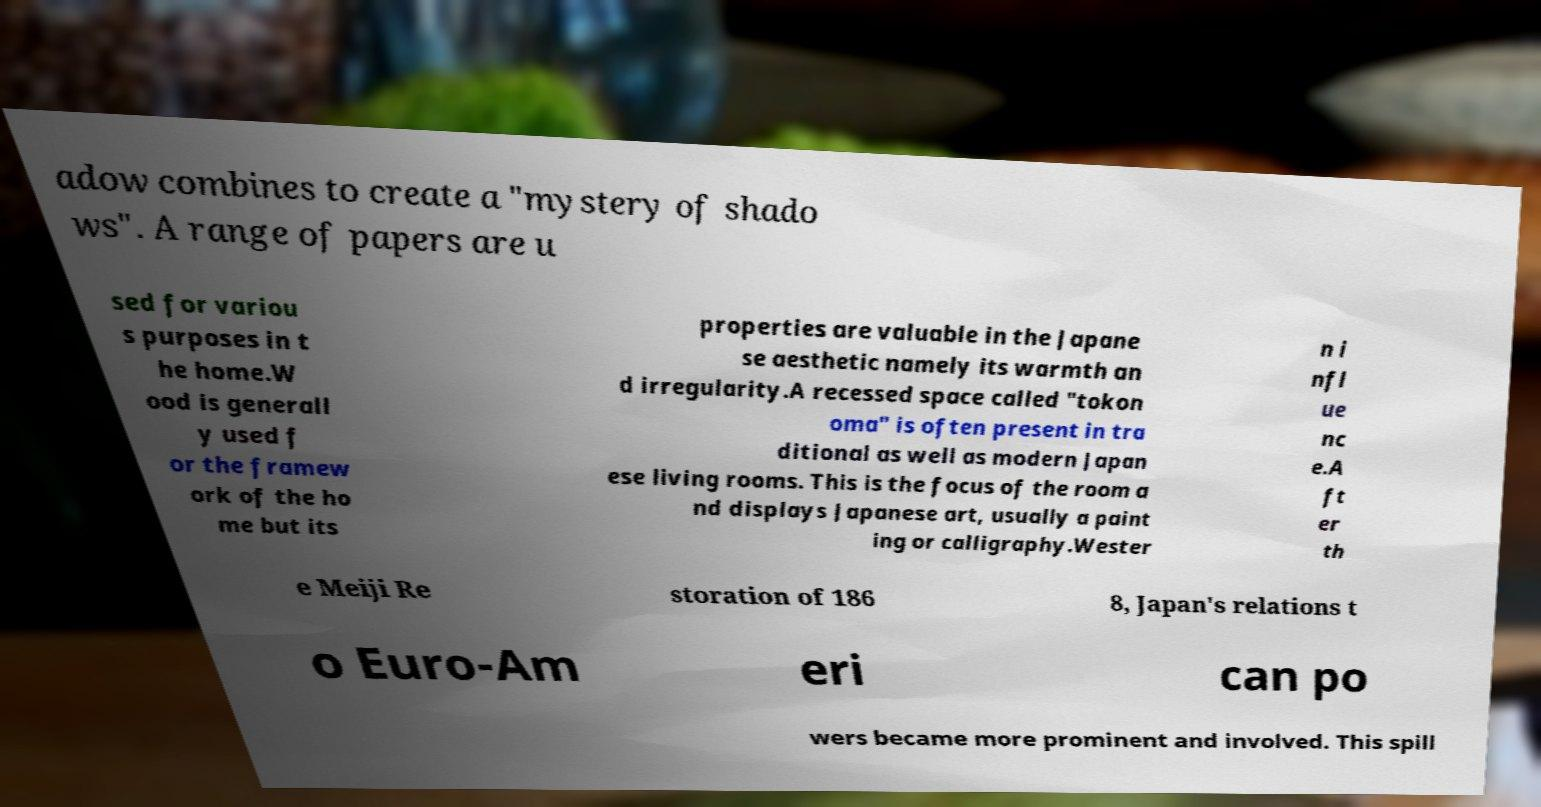Please identify and transcribe the text found in this image. adow combines to create a "mystery of shado ws". A range of papers are u sed for variou s purposes in t he home.W ood is generall y used f or the framew ork of the ho me but its properties are valuable in the Japane se aesthetic namely its warmth an d irregularity.A recessed space called "tokon oma" is often present in tra ditional as well as modern Japan ese living rooms. This is the focus of the room a nd displays Japanese art, usually a paint ing or calligraphy.Wester n i nfl ue nc e.A ft er th e Meiji Re storation of 186 8, Japan's relations t o Euro-Am eri can po wers became more prominent and involved. This spill 